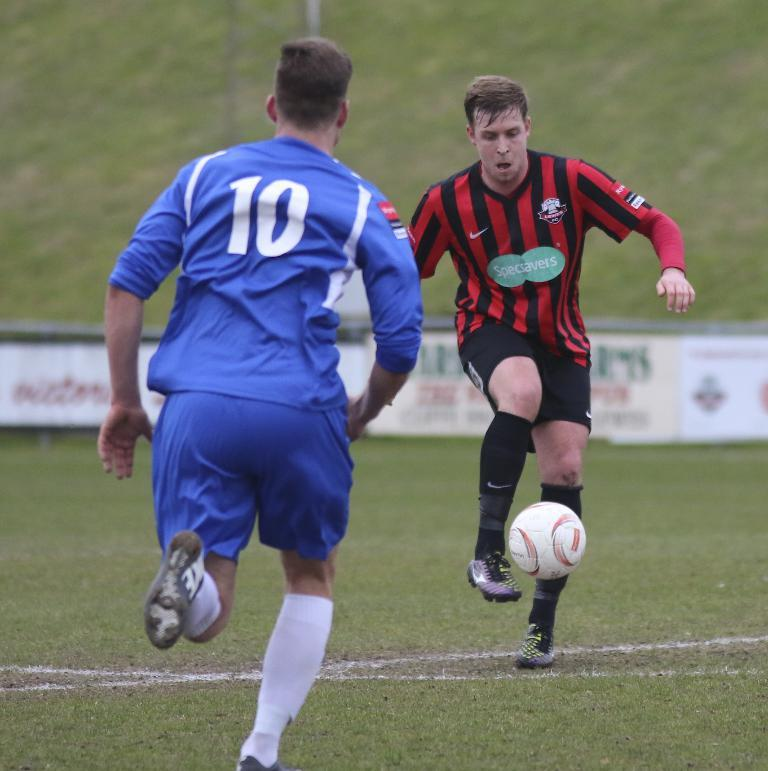How many people are in the image? There are two people in the image. What activity are the people engaged in? The two people are playing football. Where is the football game taking place? The football game is taking place on the ground. What type of rail can be seen in the image? There is no rail present in the image; it features two people playing football on the ground. 